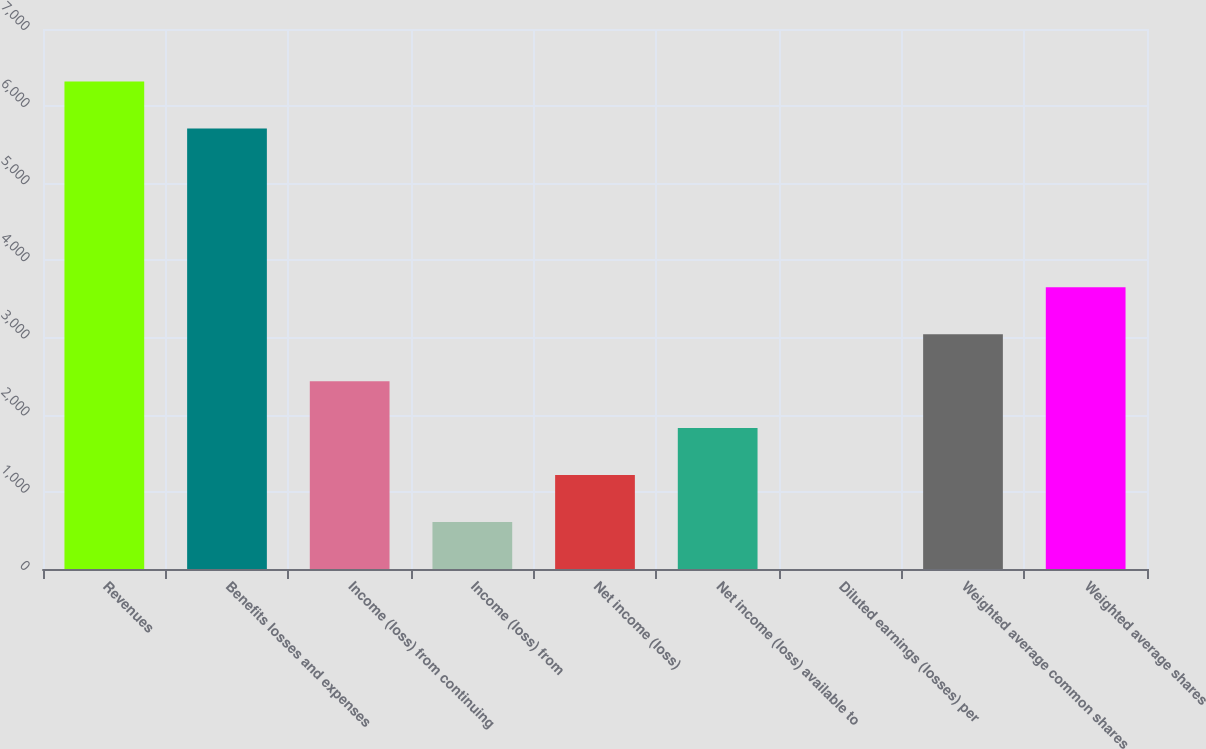Convert chart. <chart><loc_0><loc_0><loc_500><loc_500><bar_chart><fcel>Revenues<fcel>Benefits losses and expenses<fcel>Income (loss) from continuing<fcel>Income (loss) from<fcel>Net income (loss)<fcel>Net income (loss) available to<fcel>Diluted earnings (losses) per<fcel>Weighted average common shares<fcel>Weighted average shares<nl><fcel>6318.64<fcel>5710<fcel>2435.2<fcel>609.29<fcel>1217.93<fcel>1826.57<fcel>0.65<fcel>3043.84<fcel>3652.48<nl></chart> 